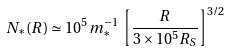Convert formula to latex. <formula><loc_0><loc_0><loc_500><loc_500>N _ { * } ( R ) \simeq 1 0 ^ { 5 } \, m _ { * } ^ { - 1 } \, \left [ \frac { R } { 3 \times 1 0 ^ { 5 } R _ { S } } \right ] ^ { 3 / 2 }</formula> 